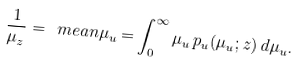<formula> <loc_0><loc_0><loc_500><loc_500>\frac { 1 } { \mu _ { z } } = \ m e a n { \mu _ { u } } = \int _ { 0 } ^ { \infty } \mu _ { u } \, p _ { u } ( \mu _ { u } ; z ) \, d \mu _ { u } .</formula> 